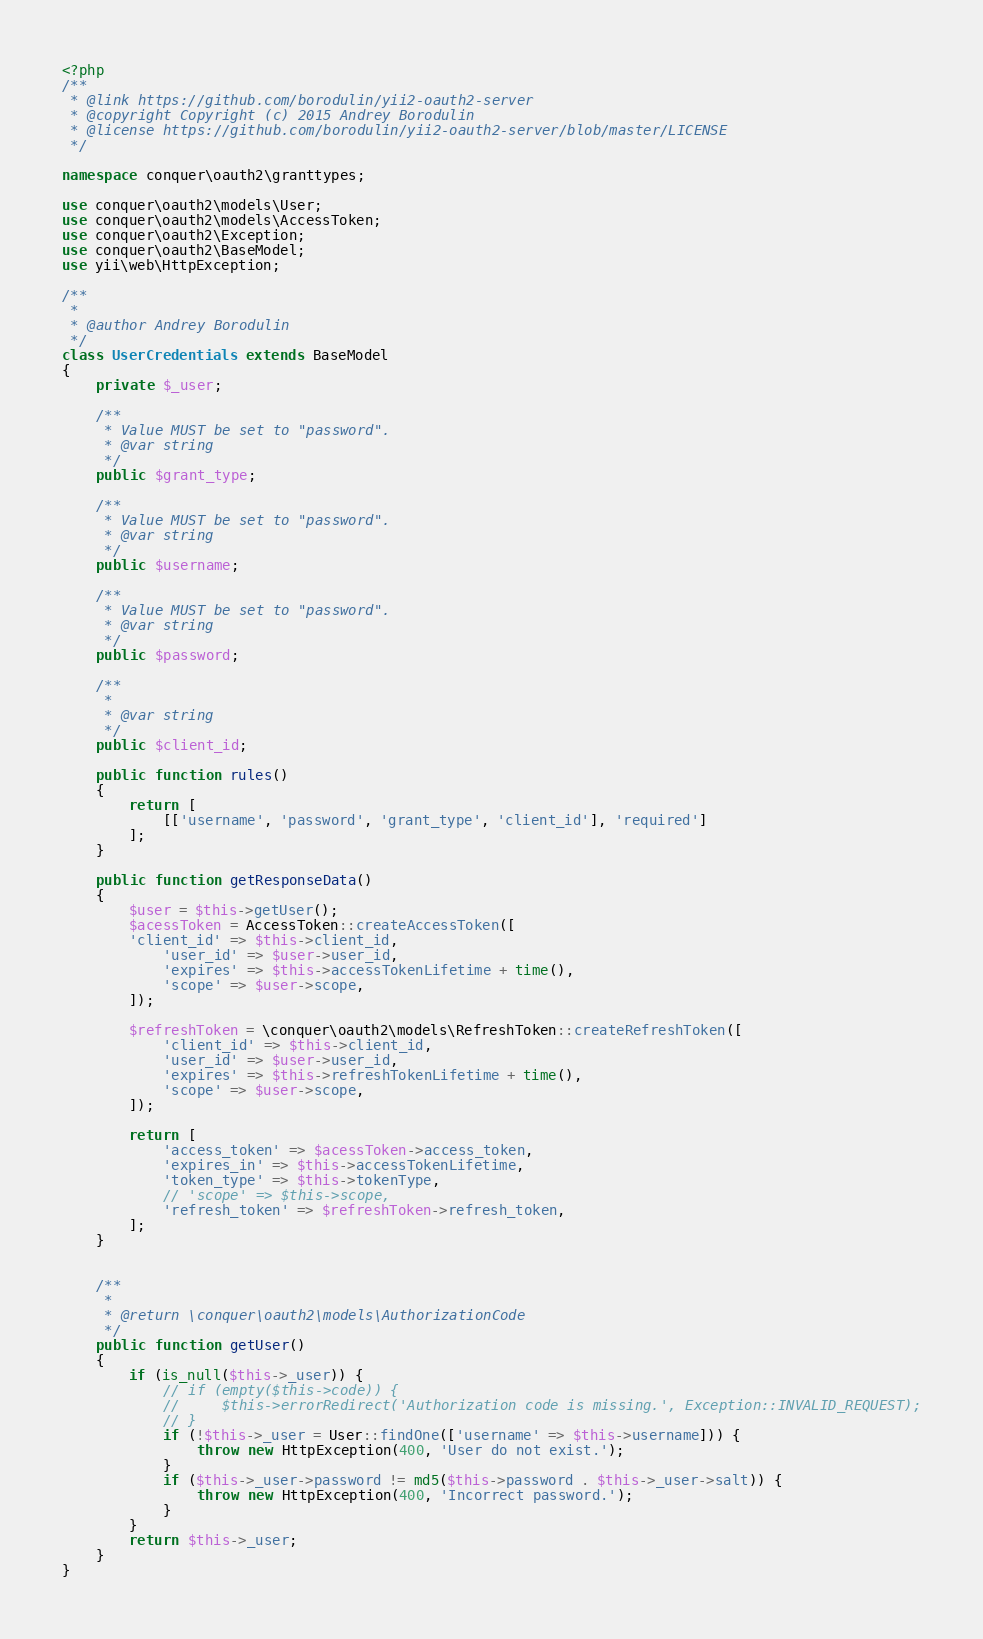<code> <loc_0><loc_0><loc_500><loc_500><_PHP_><?php
/**
 * @link https://github.com/borodulin/yii2-oauth2-server
 * @copyright Copyright (c) 2015 Andrey Borodulin
 * @license https://github.com/borodulin/yii2-oauth2-server/blob/master/LICENSE
 */

namespace conquer\oauth2\granttypes;

use conquer\oauth2\models\User;
use conquer\oauth2\models\AccessToken;
use conquer\oauth2\Exception;
use conquer\oauth2\BaseModel;
use yii\web\HttpException;

/**
 *
 * @author Andrey Borodulin
 */
class UserCredentials extends BaseModel
{
    private $_user;

    /**
     * Value MUST be set to "password".
     * @var string
     */
    public $grant_type;

    /**
     * Value MUST be set to "password".
     * @var string
     */
    public $username;

    /**
     * Value MUST be set to "password".
     * @var string
     */
    public $password;

    /**
     *
     * @var string
     */
    public $client_id;

    public function rules()
    {
        return [
            [['username', 'password', 'grant_type', 'client_id'], 'required']
        ];
    }

    public function getResponseData()
    {
        $user = $this->getUser();
        $acessToken = AccessToken::createAccessToken([
	    'client_id' => $this->client_id,
            'user_id' => $user->user_id,
            'expires' => $this->accessTokenLifetime + time(),
            'scope' => $user->scope,
        ]);

	    $refreshToken = \conquer\oauth2\models\RefreshToken::createRefreshToken([
		    'client_id' => $this->client_id,
		    'user_id' => $user->user_id,
		    'expires' => $this->refreshTokenLifetime + time(),
		    'scope' => $user->scope,
	    ]);

        return [
            'access_token' => $acessToken->access_token,
            'expires_in' => $this->accessTokenLifetime,
            'token_type' => $this->tokenType,
            // 'scope' => $this->scope,
	        'refresh_token' => $refreshToken->refresh_token,
        ];
    }


    /**
     *
     * @return \conquer\oauth2\models\AuthorizationCode
     */
    public function getUser()
    {
        if (is_null($this->_user)) {
            // if (empty($this->code)) {
            //     $this->errorRedirect('Authorization code is missing.', Exception::INVALID_REQUEST);
            // }
            if (!$this->_user = User::findOne(['username' => $this->username])) {
                throw new HttpException(400, 'User do not exist.');
            }
            if ($this->_user->password != md5($this->password . $this->_user->salt)) {
                throw new HttpException(400, 'Incorrect password.');
            }
        }
        return $this->_user;
    }
}
</code> 